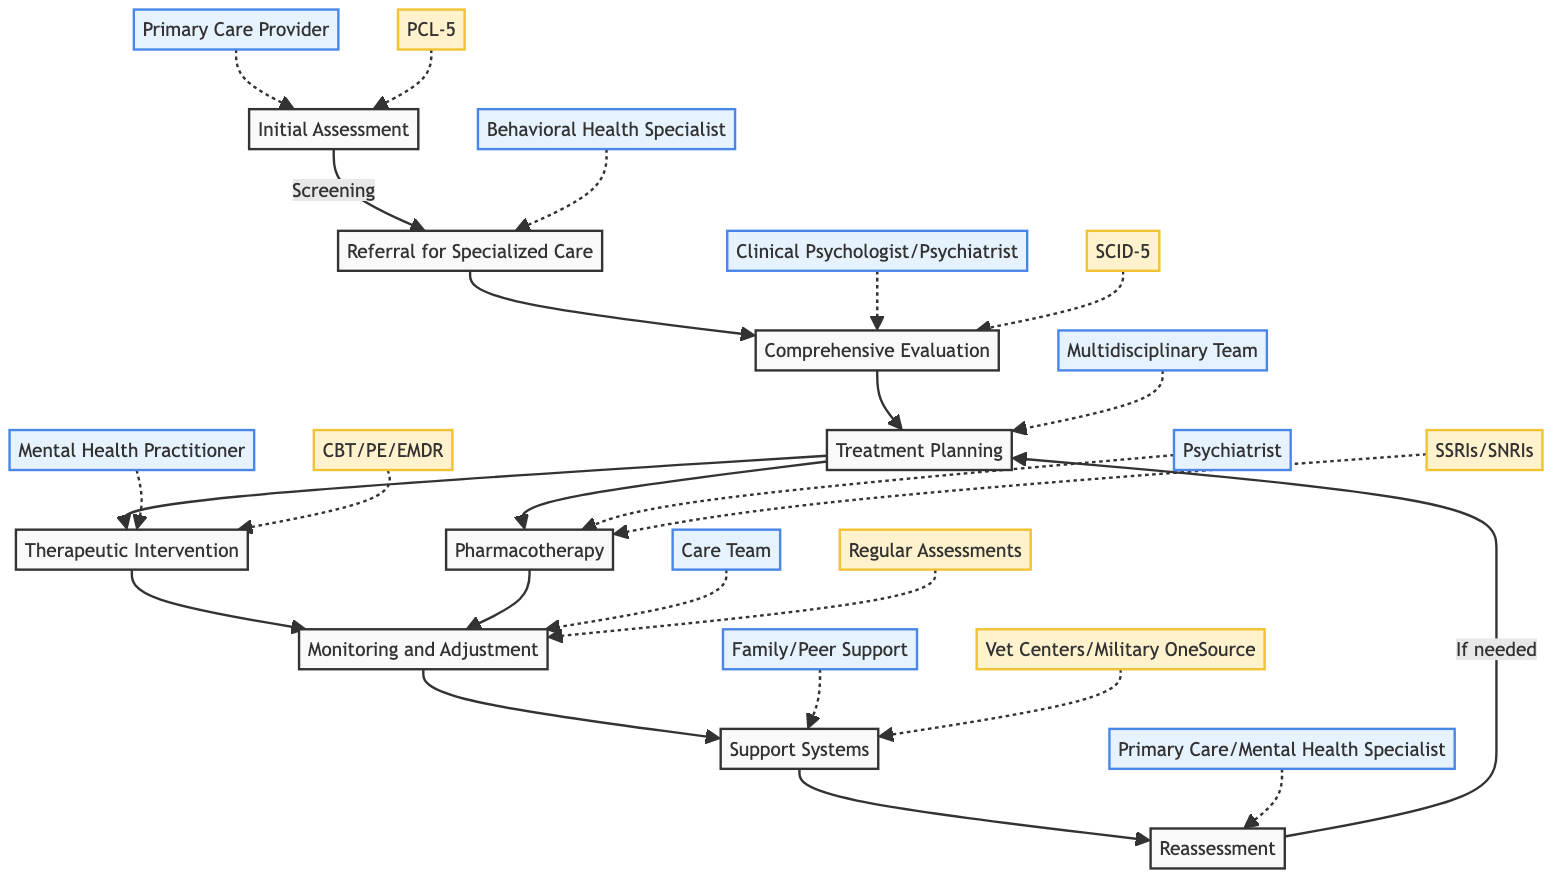What is the first step in the timeline? The first step in the timeline is labeled "Initial Assessment," which focuses on "Screening."
Answer: Initial Assessment Who conducts the initial assessment? The entity responsible for the initial assessment is the "Primary Care Provider."
Answer: Primary Care Provider What tool is used for screening? The tool utilized for screening in the initial assessment is the "PTSD Checklist for DSM-5 (PCL-5)."
Answer: PTSD Checklist for DSM-5 (PCL-5) How many therapeutic types are listed? There are three types of therapy mentioned under "Therapeutic Intervention": Cognitive Behavioral Therapy, Prolonged Exposure Therapy, and Eye Movement Desensitization and Reprocessing.
Answer: 3 What step follows "Treatment Planning"? The step that follows "Treatment Planning" is "Therapeutic Intervention."
Answer: Therapeutic Intervention Who is responsible for the ongoing monitoring? The entity responsible for ongoing monitoring is the "Care Team."
Answer: Care Team What is the frequency of periodic reassessment? The frequency for periodic reassessment is "Every 6-12 Months."
Answer: Every 6-12 Months What entities are involved in the support systems? The entities involved in the support systems are "Family Members" and "Veteran Support Groups."
Answer: Family Members, Veteran Support Groups Which step involves creating a treatment plan? The step that involves creating a treatment plan is "Treatment Planning."
Answer: Treatment Planning What are the two medication types listed? The two types of medication listed are "Selective Serotonin Reuptake Inhibitors (SSRIs)" and "Serotonin-Norepinephrine Reuptake Inhibitors (SNRIs)."
Answer: SSRIs, SNRIs 